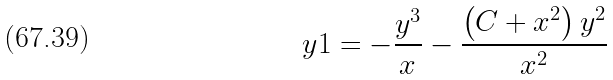Convert formula to latex. <formula><loc_0><loc_0><loc_500><loc_500>\ y 1 = - { \frac { { y } ^ { 3 } } { x } } - { \frac { \left ( C + { x } ^ { 2 } \right ) { y } ^ { 2 } } { { x } ^ { 2 } } }</formula> 